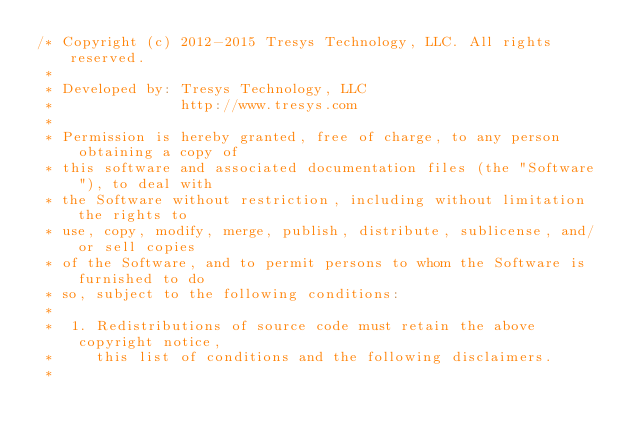<code> <loc_0><loc_0><loc_500><loc_500><_Scala_>/* Copyright (c) 2012-2015 Tresys Technology, LLC. All rights reserved.
 *
 * Developed by: Tresys Technology, LLC
 *               http://www.tresys.com
 *
 * Permission is hereby granted, free of charge, to any person obtaining a copy of
 * this software and associated documentation files (the "Software"), to deal with
 * the Software without restriction, including without limitation the rights to
 * use, copy, modify, merge, publish, distribute, sublicense, and/or sell copies
 * of the Software, and to permit persons to whom the Software is furnished to do
 * so, subject to the following conditions:
 *
 *  1. Redistributions of source code must retain the above copyright notice,
 *     this list of conditions and the following disclaimers.
 *</code> 